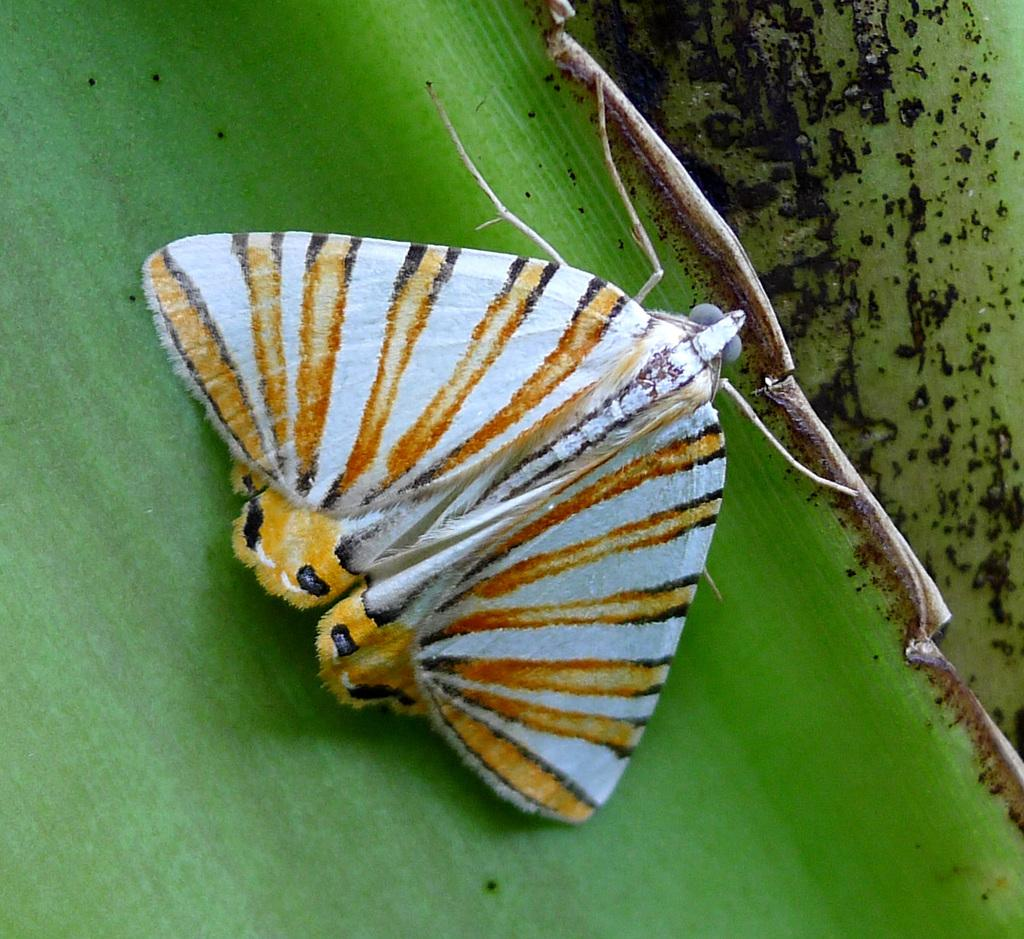What is the main subject of the image? There is a butterfly in the image. Where is the butterfly located? The butterfly is on a leaf. What sense does the owl use to detect the butterfly in the image? There is no owl present in the image, so it is not possible to determine which sense the owl might use to detect the butterfly. 